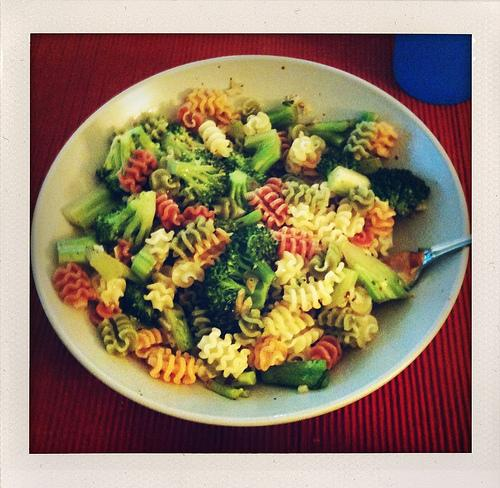What is the color and pattern of the place setting beneath the plate? The place setting is red with stripes, located under the round white bowl. Identify the primary object that contains vegetables in the image. A white bowl of broccoli and pasta is the main object containing vegetables. Describe the position of the cup in relation to the bowl. The cup is blue and located next to the white round bowl. What type of table accessory is located under the bowl? A striped red placemat is located under the bowl. In which object can you find the broccoli pieces? The broccoli pieces are found in a round white bowl of food. What is the main ingredient in the bowl, and what are its accompanying vegetables? The main ingredient in the bowl is multicolored pasta, accompanied by chunks of broccoli. Mention the primary food item in the image and its various color variations. The primary food item is pasta, and it has white, orange, and green color variations. List three different colors of pasta found in the bowl of food. White, orange, and green pasta noodles are found in the bowl of food. What type of utensil is in the bowl, and what is its material? A fork is in the bowl, and it is made of silver. Describe the appearance and location of the drinking vessel in the image. A blue cup is located next to the bowl and has a dark blue color. 